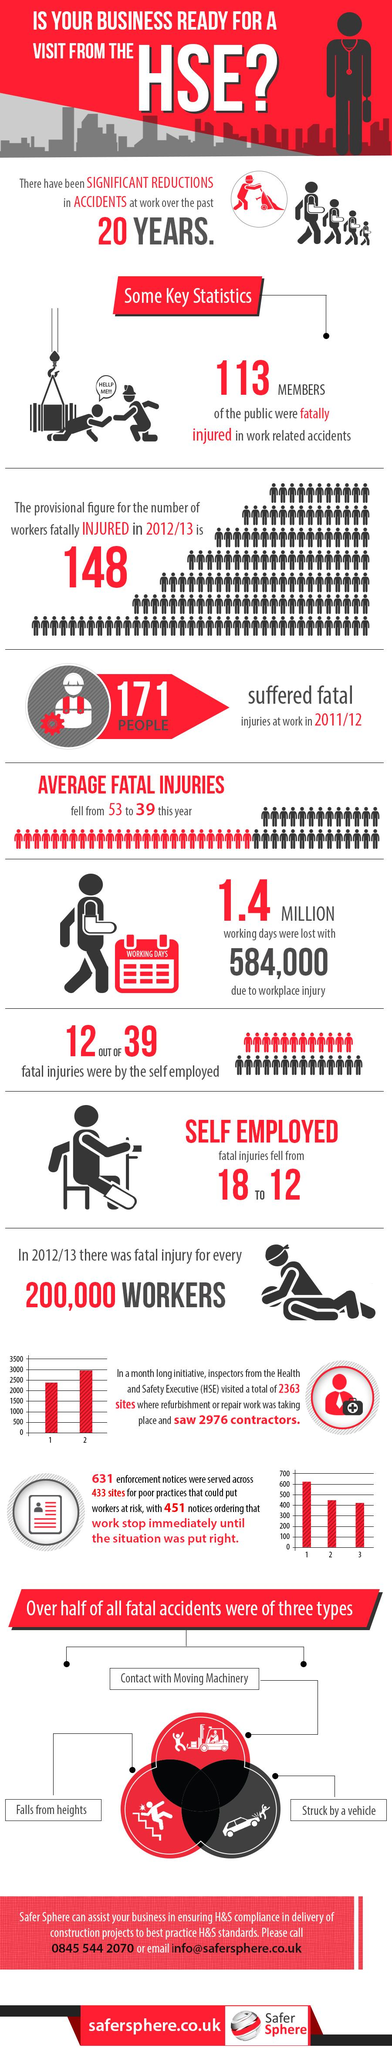Specify some key components in this picture. The average number of fatal injuries fell by 14 this year. Out of the 39 reported injuries, only 27 were not caused by the self-employed. The main reasons for more than half of all fatal accidents were contact with moving machinery, falls from heights, and being struck by a vehicle. 